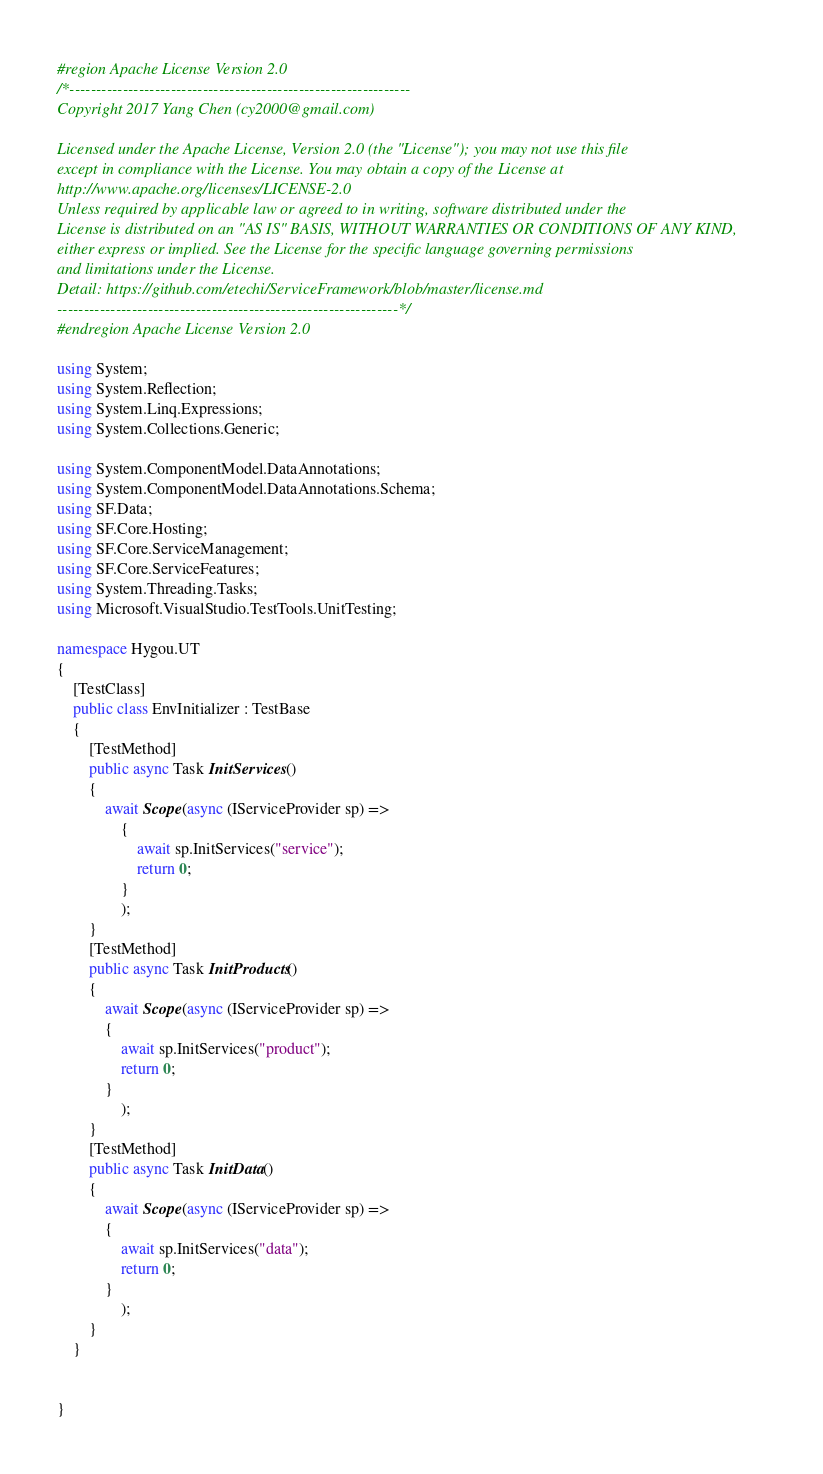Convert code to text. <code><loc_0><loc_0><loc_500><loc_500><_C#_>#region Apache License Version 2.0
/*----------------------------------------------------------------
Copyright 2017 Yang Chen (cy2000@gmail.com)

Licensed under the Apache License, Version 2.0 (the "License"); you may not use this file
except in compliance with the License. You may obtain a copy of the License at
http://www.apache.org/licenses/LICENSE-2.0
Unless required by applicable law or agreed to in writing, software distributed under the
License is distributed on an "AS IS" BASIS, WITHOUT WARRANTIES OR CONDITIONS OF ANY KIND,
either express or implied. See the License for the specific language governing permissions
and limitations under the License.
Detail: https://github.com/etechi/ServiceFramework/blob/master/license.md
----------------------------------------------------------------*/
#endregion Apache License Version 2.0

using System;
using System.Reflection;
using System.Linq.Expressions;
using System.Collections.Generic;

using System.ComponentModel.DataAnnotations;
using System.ComponentModel.DataAnnotations.Schema;
using SF.Data;
using SF.Core.Hosting;
using SF.Core.ServiceManagement;
using SF.Core.ServiceFeatures;
using System.Threading.Tasks;
using Microsoft.VisualStudio.TestTools.UnitTesting;

namespace Hygou.UT
{
	[TestClass]
	public class EnvInitializer : TestBase
	{
		[TestMethod]
		public async Task InitServices()
		{
			await Scope(async (IServiceProvider sp) =>
				{
					await sp.InitServices("service");
					return 0;
				}
				);
		}
		[TestMethod]
		public async Task InitProducts()
		{
			await Scope(async (IServiceProvider sp) =>
			{
				await sp.InitServices("product");
				return 0;
			}
				);
		}
		[TestMethod]
		public async Task InitData()
		{
			await Scope(async (IServiceProvider sp) =>
			{
				await sp.InitServices("data");
				return 0;
			}
				);
		}
	}
	

}
</code> 